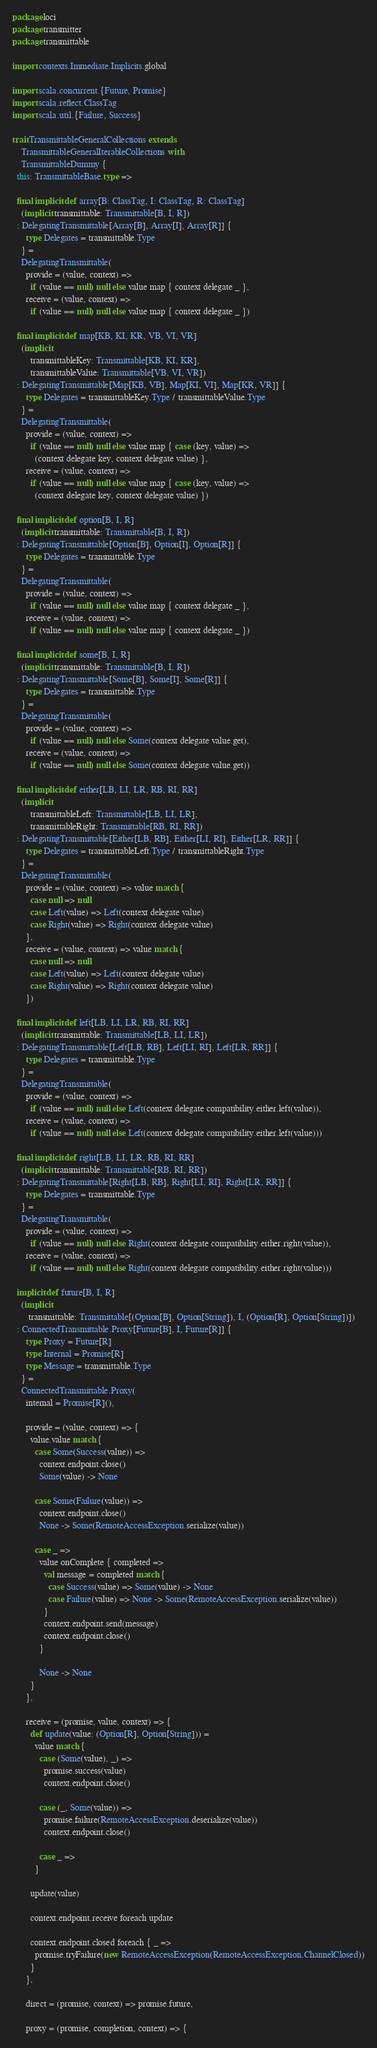Convert code to text. <code><loc_0><loc_0><loc_500><loc_500><_Scala_>package loci
package transmitter
package transmittable

import contexts.Immediate.Implicits.global

import scala.concurrent.{Future, Promise}
import scala.reflect.ClassTag
import scala.util.{Failure, Success}

trait TransmittableGeneralCollections extends
    TransmittableGeneralIterableCollections with
    TransmittableDummy {
  this: TransmittableBase.type =>

  final implicit def array[B: ClassTag, I: ClassTag, R: ClassTag]
    (implicit transmittable: Transmittable[B, I, R])
  : DelegatingTransmittable[Array[B], Array[I], Array[R]] {
      type Delegates = transmittable.Type
    } =
    DelegatingTransmittable(
      provide = (value, context) =>
        if (value == null) null else value map { context delegate _ },
      receive = (value, context) =>
        if (value == null) null else value map { context delegate _ })

  final implicit def map[KB, KI, KR, VB, VI, VR]
    (implicit
        transmittableKey: Transmittable[KB, KI, KR],
        transmittableValue: Transmittable[VB, VI, VR])
  : DelegatingTransmittable[Map[KB, VB], Map[KI, VI], Map[KR, VR]] {
      type Delegates = transmittableKey.Type / transmittableValue.Type
    } =
    DelegatingTransmittable(
      provide = (value, context) =>
        if (value == null) null else value map { case (key, value) =>
          (context delegate key, context delegate value) },
      receive = (value, context) =>
        if (value == null) null else value map { case (key, value) =>
          (context delegate key, context delegate value) })

  final implicit def option[B, I, R]
    (implicit transmittable: Transmittable[B, I, R])
  : DelegatingTransmittable[Option[B], Option[I], Option[R]] {
      type Delegates = transmittable.Type
    } =
    DelegatingTransmittable(
      provide = (value, context) =>
        if (value == null) null else value map { context delegate _ },
      receive = (value, context) =>
        if (value == null) null else value map { context delegate _ })

  final implicit def some[B, I, R]
    (implicit transmittable: Transmittable[B, I, R])
  : DelegatingTransmittable[Some[B], Some[I], Some[R]] {
      type Delegates = transmittable.Type
    } =
    DelegatingTransmittable(
      provide = (value, context) =>
        if (value == null) null else Some(context delegate value.get),
      receive = (value, context) =>
        if (value == null) null else Some(context delegate value.get))

  final implicit def either[LB, LI, LR, RB, RI, RR]
    (implicit
        transmittableLeft: Transmittable[LB, LI, LR],
        transmittableRight: Transmittable[RB, RI, RR])
  : DelegatingTransmittable[Either[LB, RB], Either[LI, RI], Either[LR, RR]] {
      type Delegates = transmittableLeft.Type / transmittableRight.Type
    } =
    DelegatingTransmittable(
      provide = (value, context) => value match {
        case null => null
        case Left(value) => Left(context delegate value)
        case Right(value) => Right(context delegate value)
      },
      receive = (value, context) => value match {
        case null => null
        case Left(value) => Left(context delegate value)
        case Right(value) => Right(context delegate value)
      })

  final implicit def left[LB, LI, LR, RB, RI, RR]
    (implicit transmittable: Transmittable[LB, LI, LR])
  : DelegatingTransmittable[Left[LB, RB], Left[LI, RI], Left[LR, RR]] {
      type Delegates = transmittable.Type
    } =
    DelegatingTransmittable(
      provide = (value, context) =>
        if (value == null) null else Left(context delegate compatibility.either.left(value)),
      receive = (value, context) =>
        if (value == null) null else Left(context delegate compatibility.either.left(value)))

  final implicit def right[LB, LI, LR, RB, RI, RR]
    (implicit transmittable: Transmittable[RB, RI, RR])
  : DelegatingTransmittable[Right[LB, RB], Right[LI, RI], Right[LR, RR]] {
      type Delegates = transmittable.Type
    } =
    DelegatingTransmittable(
      provide = (value, context) =>
        if (value == null) null else Right(context delegate compatibility.either.right(value)),
      receive = (value, context) =>
        if (value == null) null else Right(context delegate compatibility.either.right(value)))

  implicit def future[B, I, R]
    (implicit
       transmittable: Transmittable[(Option[B], Option[String]), I, (Option[R], Option[String])])
  : ConnectedTransmittable.Proxy[Future[B], I, Future[R]] {
      type Proxy = Future[R]
      type Internal = Promise[R]
      type Message = transmittable.Type
    } =
    ConnectedTransmittable.Proxy(
      internal = Promise[R](),

      provide = (value, context) => {
        value.value match {
          case Some(Success(value)) =>
            context.endpoint.close()
            Some(value) -> None

          case Some(Failure(value)) =>
            context.endpoint.close()
            None -> Some(RemoteAccessException.serialize(value))

          case _ =>
            value onComplete { completed =>
              val message = completed match {
                case Success(value) => Some(value) -> None
                case Failure(value) => None -> Some(RemoteAccessException.serialize(value))
              }
              context.endpoint.send(message)
              context.endpoint.close()
            }

            None -> None
        }
      },

      receive = (promise, value, context) => {
        def update(value: (Option[R], Option[String])) =
          value match {
            case (Some(value), _) =>
              promise.success(value)
              context.endpoint.close()

            case (_, Some(value)) =>
              promise.failure(RemoteAccessException.deserialize(value))
              context.endpoint.close()

            case _ =>
          }

        update(value)

        context.endpoint.receive foreach update

        context.endpoint.closed foreach { _ =>
          promise.tryFailure(new RemoteAccessException(RemoteAccessException.ChannelClosed))
        }
      },

      direct = (promise, context) => promise.future,

      proxy = (promise, completion, context) => {</code> 